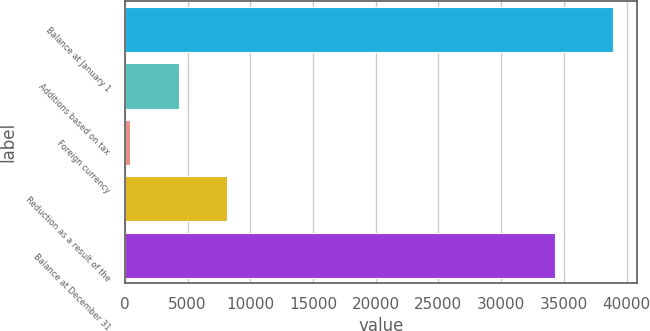<chart> <loc_0><loc_0><loc_500><loc_500><bar_chart><fcel>Balance at January 1<fcel>Additions based on tax<fcel>Foreign currency<fcel>Reduction as a result of the<fcel>Balance at December 31<nl><fcel>38886<fcel>4283.7<fcel>439<fcel>8128.4<fcel>34337<nl></chart> 